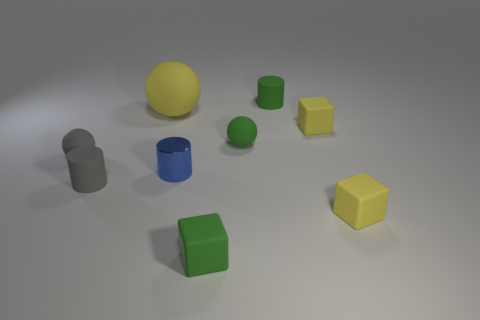Is there anything else that has the same material as the blue cylinder?
Offer a very short reply. No. Is the number of small red cylinders greater than the number of blue metallic cylinders?
Offer a terse response. No. There is a block to the left of the cylinder that is behind the small yellow cube behind the tiny blue cylinder; what is its size?
Give a very brief answer. Small. There is a yellow rubber thing on the left side of the tiny blue object; how big is it?
Make the answer very short. Large. What number of things are either red matte cylinders or small green blocks in front of the blue metallic thing?
Your answer should be very brief. 1. How many other objects are the same size as the blue cylinder?
Provide a short and direct response. 7. Are there more tiny green blocks that are to the right of the gray rubber cylinder than large blue rubber spheres?
Give a very brief answer. Yes. Is there any other thing that has the same color as the large rubber object?
Provide a short and direct response. Yes. There is a big object that is the same material as the green cube; what shape is it?
Provide a short and direct response. Sphere. Does the small cylinder behind the big rubber thing have the same material as the gray ball?
Provide a succinct answer. Yes. 